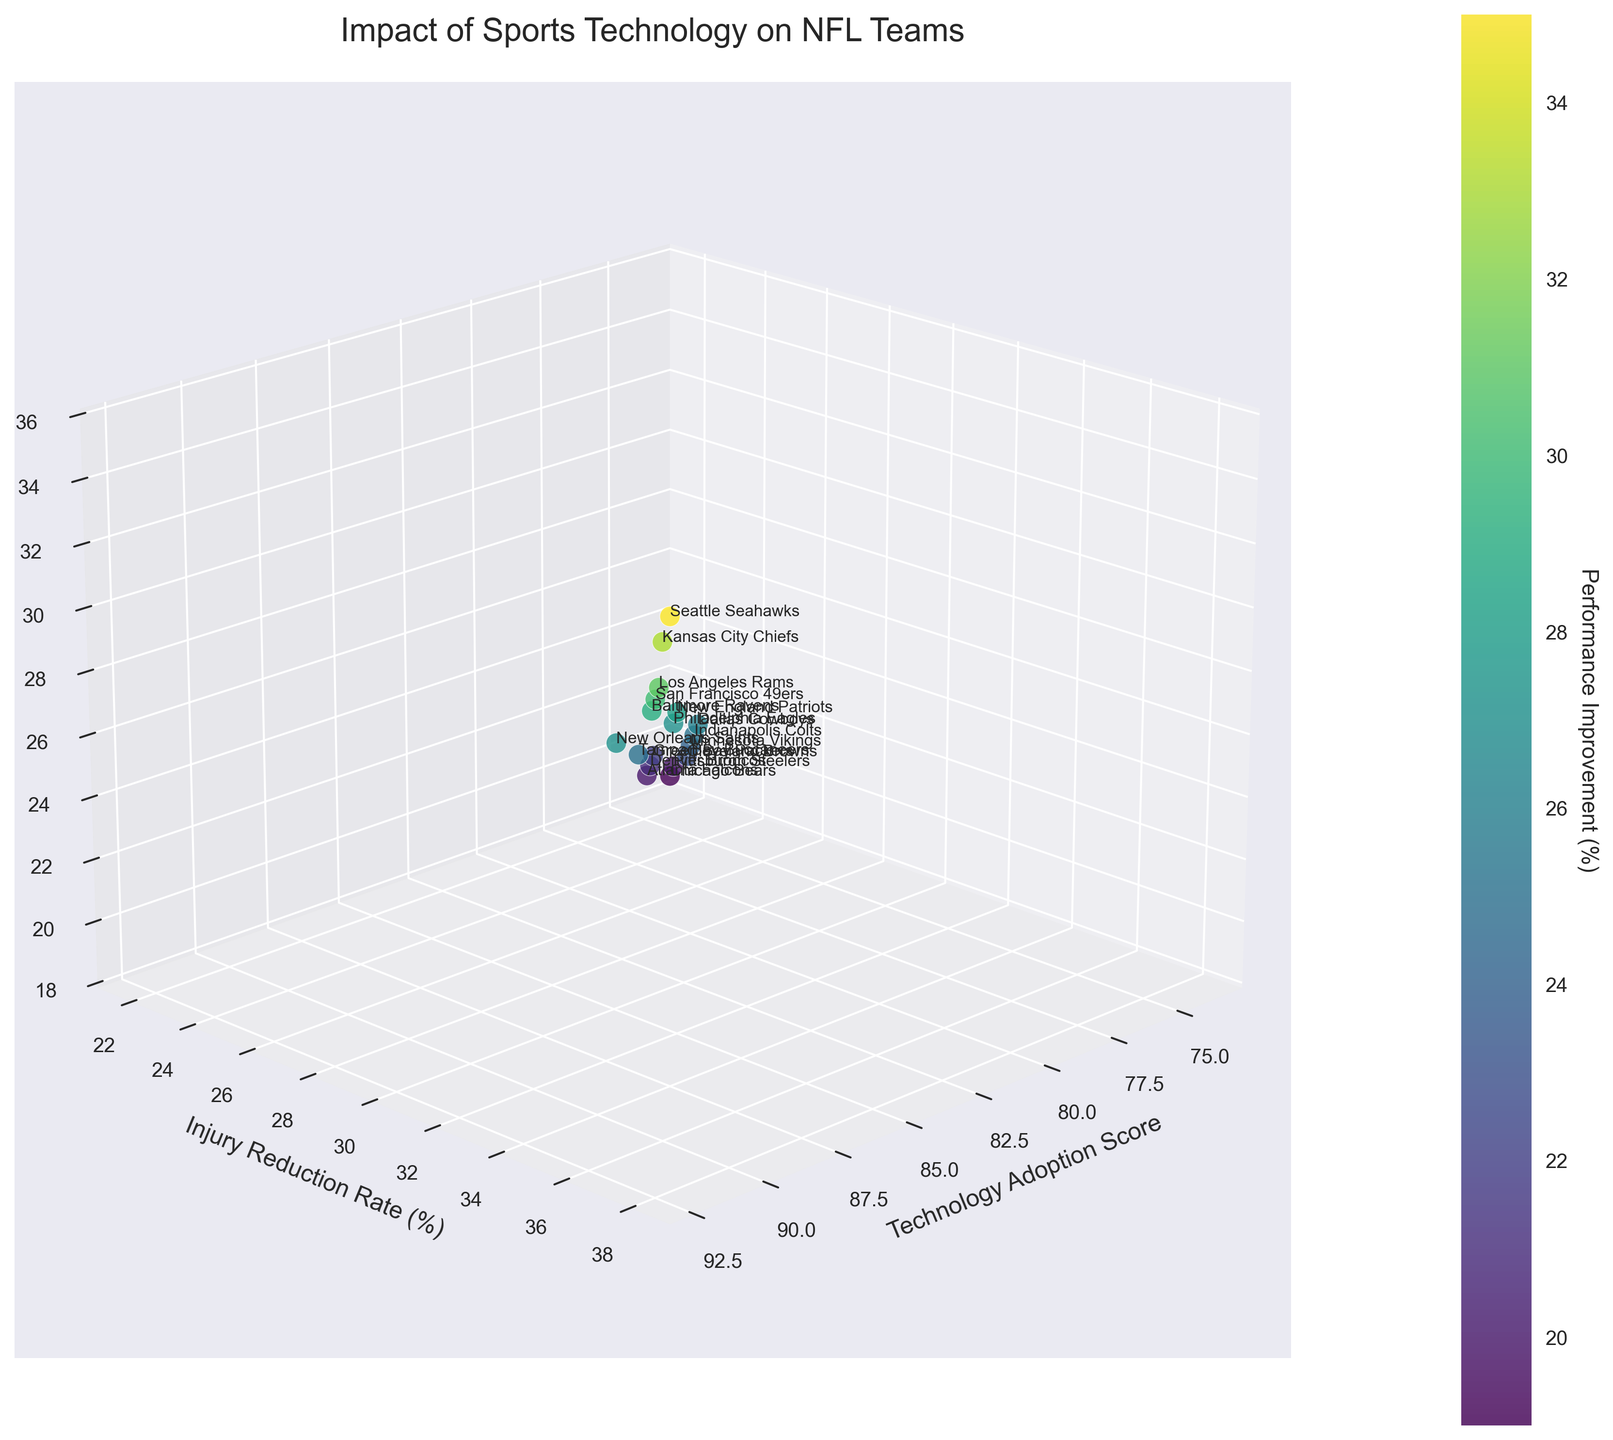What is the title of this figure? The title of the figure is usually found at the top. By referring to the figure, one can see that the title is clearly displayed as 'Impact of Sports Technology on NFL Teams'.
Answer: Impact of Sports Technology on NFL Teams What's the label on the x-axis? Examining the figure, the label for the x-axis can be seen near the horizontal axis at the bottom. It is 'Technology Adoption Score'.
Answer: Technology Adoption Score How many NFL teams are represented in the plot? Each data point in the 3D scatter plot corresponds to an NFL team. By counting all the individual data points in the plot, we can find the total number.
Answer: 18 Which NFL team has the highest Technology Adoption Score? By looking at the position of the data points on the x-axis, the team with the highest score will be the furthest along the positive x-axis. The highest Technology Adoption Score is 92, belonging to the Seattle Seahawks.
Answer: Seattle Seahawks Which team has the highest Performance Improvement percentage? The team with the highest Performance Improvement can be found by identifying the data point that is the highest in the z-axis. This is also indicated by the color gradient where the highest values will be close to yellow (in the 'viridis' colormap). The highest Performance Improvement percentage is 35%, belonging to the Seattle Seahawks.
Answer: Seattle Seahawks Which team has the lowest Injury Reduction Rate? To find the team with the lowest Injury Reduction Rate, observe the y-axis and identify the data point lowest along this axis. The lowest Injury Reduction Rate is 22%, corresponding to the Chicago Bears.
Answer: Chicago Bears What is the correlation between Technology Adoption Score and Performance Improvement? By looking at the general trend of the data points along the x and z axes, if the data points show an upward trend, there is likely a positive correlation. In this plot, as the Technology Adoption Score increases, the Performance Improvement percentage seems to also increase, indicating a positive correlation.
Answer: Positive correlation Which team has a higher Performance Improvement: New England Patriots or Baltimore Ravens? To compare these two teams, locate their data points on the 3D scatter plot and compare their positions along the z-axis. The New England Patriots have a Performance Improvement of 28%, and the Baltimore Ravens have 29%.
Answer: Baltimore Ravens What's the average Performance Improvement of the teams? To determine this, add up the Performance Improvement percentages of all teams and divide by the number of teams. Sum = 28 + 35 + 22 + 33 + 30 + 29 + 20 + 26 + 31 + 27 + 24 + 27 + 25 + 23 + 25 + 21 + 20 + 19 = 415. Then, divide by the number of teams, which is 18. 415 / 18 = 23.06.
Answer: 23.06 Does a higher Technology Adoption Score always guarantee a higher Injury Reduction Rate? To answer this, observe the points along the x-axis and y-axis to see if all high Technology Adoption Scores correspond to high Injury Reduction Rates. While most high Technology Adoption Scores (e.g., Seahawks, Chiefs) do result in higher Injury Reduction Rates, there are exceptions, so it does not always guarantee it.
Answer: No 